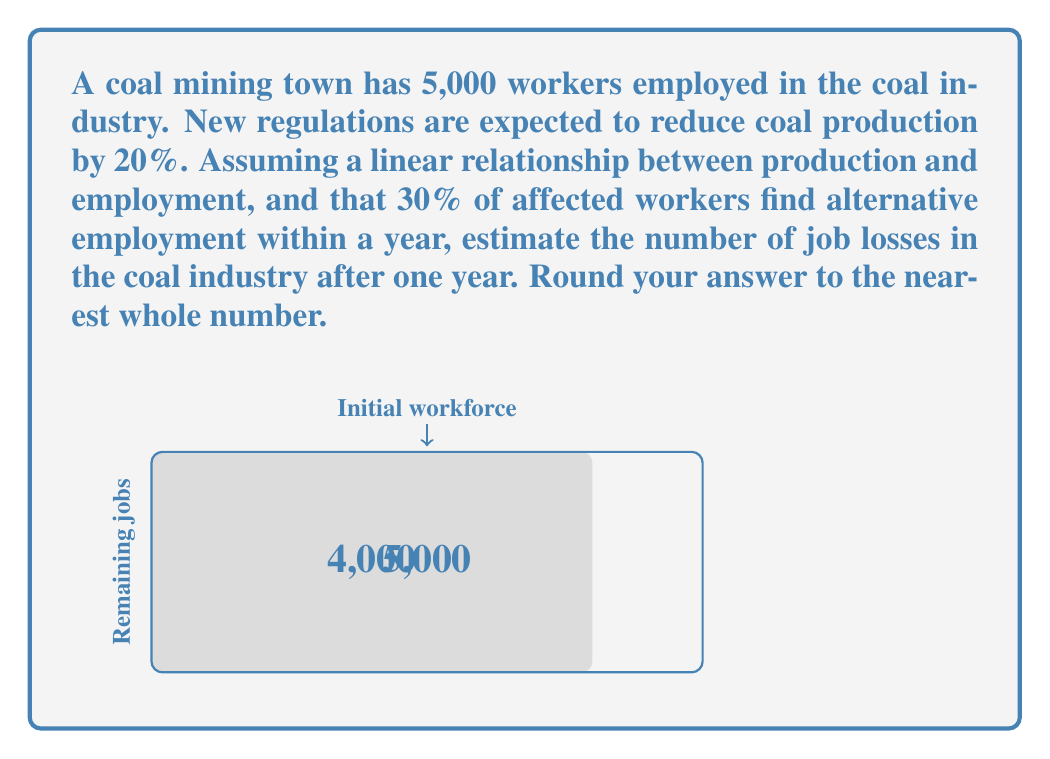Can you answer this question? Let's approach this step-by-step:

1) Initial number of workers: 5,000

2) Reduction in production: 20%
   This means the remaining production is 80% (100% - 20% = 80%)

3) Assuming a linear relationship between production and employment, we can calculate the initial job losses:
   $$\text{Initial job losses} = 5,000 \times 20\% = 5,000 \times 0.20 = 1,000$$

4) However, 30% of affected workers find alternative employment within a year:
   $$\text{Workers finding new jobs} = 1,000 \times 30\% = 1,000 \times 0.30 = 300$$

5) Therefore, the net job losses after one year:
   $$\text{Net job losses} = \text{Initial job losses} - \text{Workers finding new jobs}$$
   $$\text{Net job losses} = 1,000 - 300 = 700$$

6) Rounding to the nearest whole number: 700 (no rounding needed in this case)
Answer: 700 